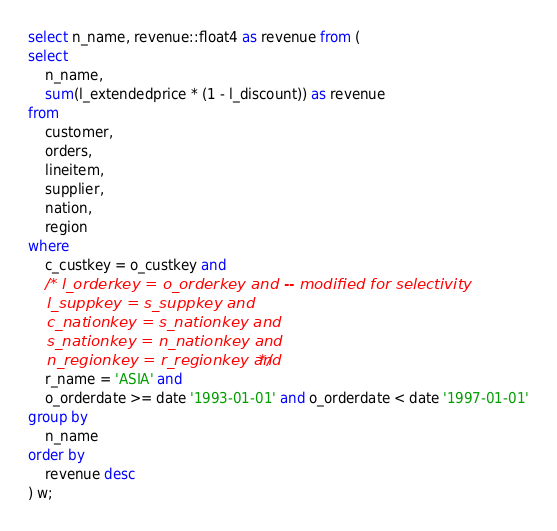Convert code to text. <code><loc_0><loc_0><loc_500><loc_500><_SQL_>select n_name, revenue::float4 as revenue from (
select
	n_name,
	sum(l_extendedprice * (1 - l_discount)) as revenue
from
	customer,
	orders,
	lineitem,
	supplier,
	nation,
	region
where
	c_custkey = o_custkey and
	/* l_orderkey = o_orderkey and -- modified for selectivity
	l_suppkey = s_suppkey and
	c_nationkey = s_nationkey and
	s_nationkey = n_nationkey and
	n_regionkey = r_regionkey and */
	r_name = 'ASIA' and
	o_orderdate >= date '1993-01-01' and o_orderdate < date '1997-01-01'
group by
	n_name
order by
	revenue desc
) w;</code> 